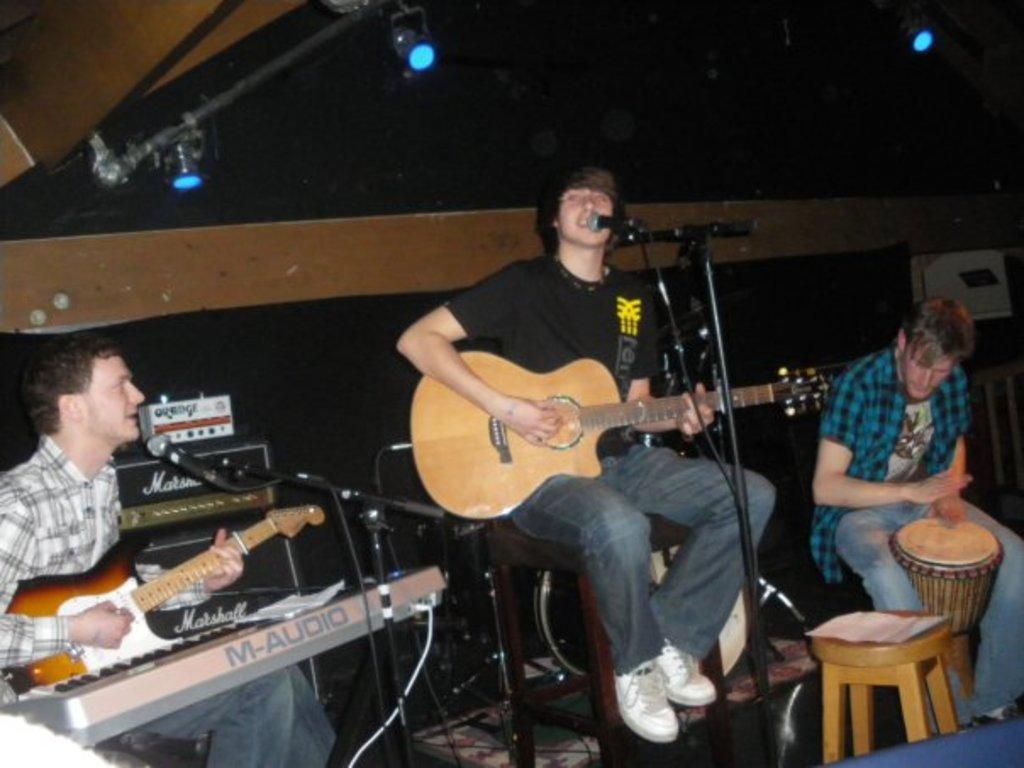Could you give a brief overview of what you see in this image? In this image 3 men who are sitting and all of them are holding musical instruments and I can also see there is a keyboard over here and there is a stool. In the background I see the lights. 